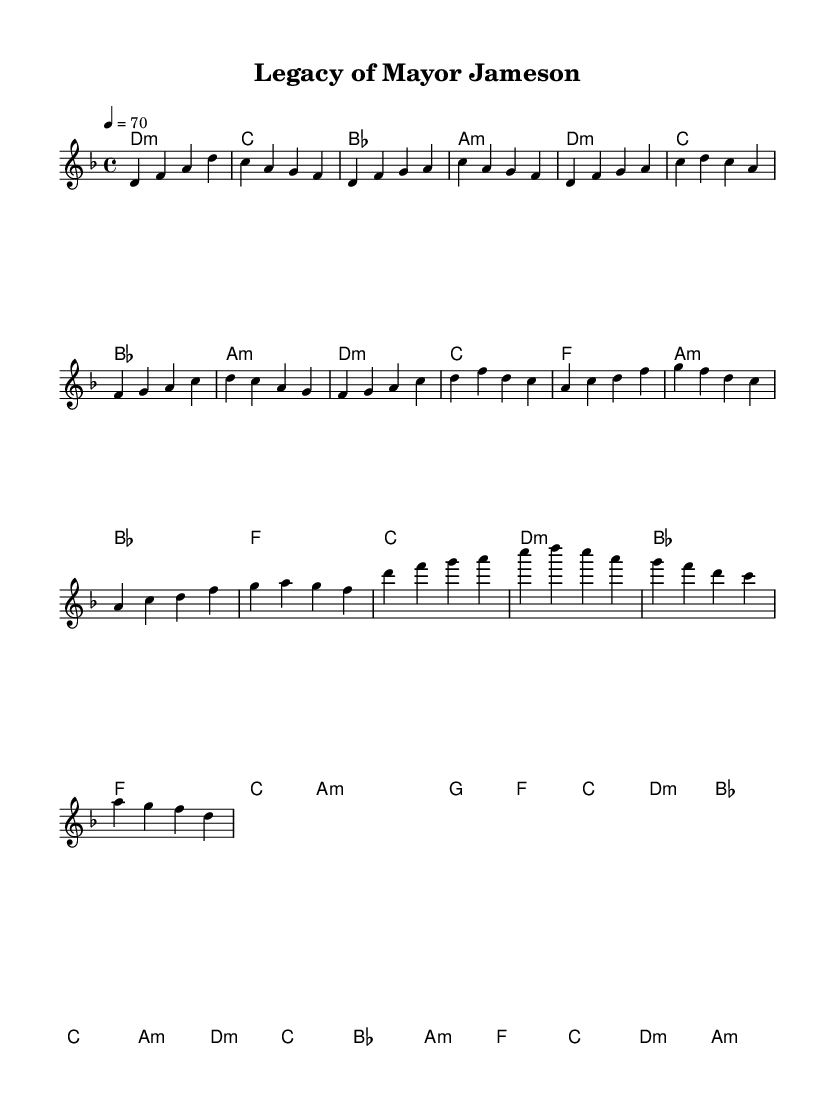What is the key signature of this music? The key signature shows two flats which indicate that the music is in D minor.
Answer: D minor What is the time signature of the piece? The time signature appears at the beginning of the music and indicates four beats per measure, which is represented by 4/4.
Answer: 4/4 What is the tempo marking for this piece? The tempo marking appears as "4 = 70," which means there are 70 beats per minute at a quarter note value.
Answer: 70 How many sections are in this composition? By analyzing the structure, the piece consists of an Intro, Verse, Chorus, Bridge, and Solo, totaling five sections.
Answer: Five Which chord is played in the bridge section? The harmonies in the bridge section start with an A minor chord, indicating the tonal foundation during that part.
Answer: A minor What is the last note of the melody in the solo section? The solo section ends with the note D, which is the last pitch written in the melody line.
Answer: D In which measure does the chorus begin? The chorus starts in measure 5 based on the sequential count from the beginning of the piece.
Answer: Five 